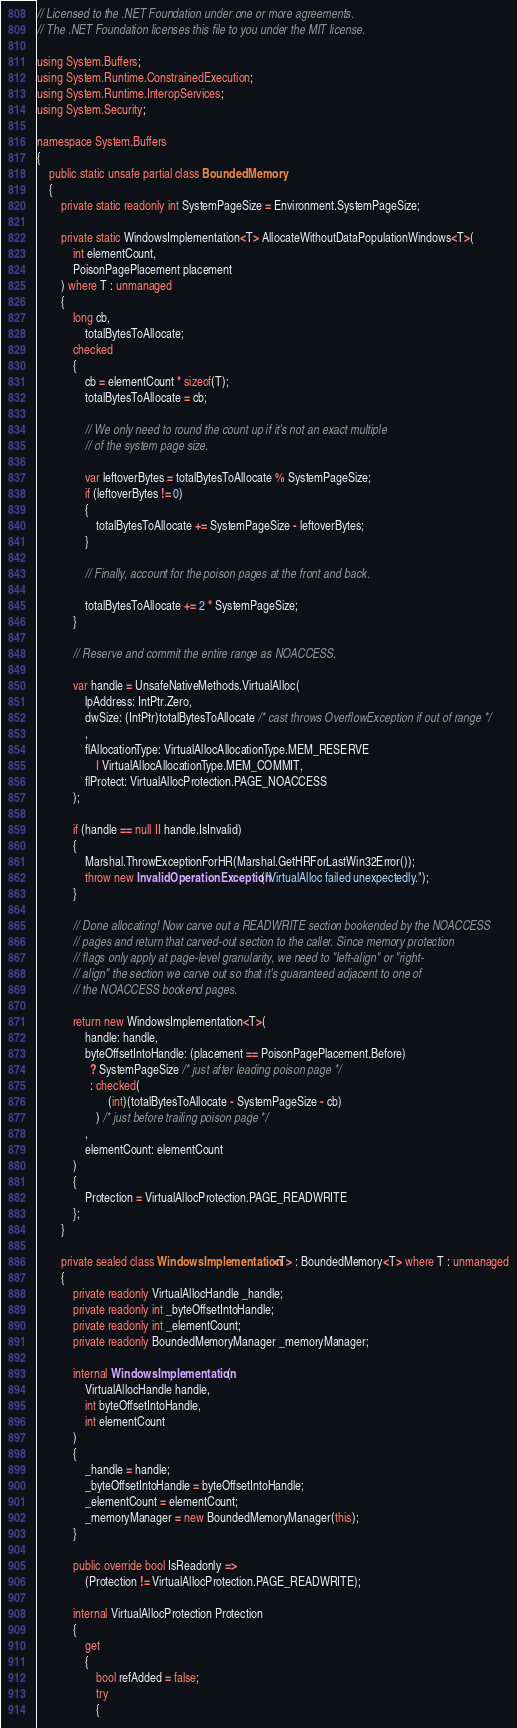Convert code to text. <code><loc_0><loc_0><loc_500><loc_500><_C#_>// Licensed to the .NET Foundation under one or more agreements.
// The .NET Foundation licenses this file to you under the MIT license.

using System.Buffers;
using System.Runtime.ConstrainedExecution;
using System.Runtime.InteropServices;
using System.Security;

namespace System.Buffers
{
    public static unsafe partial class BoundedMemory
    {
        private static readonly int SystemPageSize = Environment.SystemPageSize;

        private static WindowsImplementation<T> AllocateWithoutDataPopulationWindows<T>(
            int elementCount,
            PoisonPagePlacement placement
        ) where T : unmanaged
        {
            long cb,
                totalBytesToAllocate;
            checked
            {
                cb = elementCount * sizeof(T);
                totalBytesToAllocate = cb;

                // We only need to round the count up if it's not an exact multiple
                // of the system page size.

                var leftoverBytes = totalBytesToAllocate % SystemPageSize;
                if (leftoverBytes != 0)
                {
                    totalBytesToAllocate += SystemPageSize - leftoverBytes;
                }

                // Finally, account for the poison pages at the front and back.

                totalBytesToAllocate += 2 * SystemPageSize;
            }

            // Reserve and commit the entire range as NOACCESS.

            var handle = UnsafeNativeMethods.VirtualAlloc(
                lpAddress: IntPtr.Zero,
                dwSize: (IntPtr)totalBytesToAllocate /* cast throws OverflowException if out of range */
                ,
                flAllocationType: VirtualAllocAllocationType.MEM_RESERVE
                    | VirtualAllocAllocationType.MEM_COMMIT,
                flProtect: VirtualAllocProtection.PAGE_NOACCESS
            );

            if (handle == null || handle.IsInvalid)
            {
                Marshal.ThrowExceptionForHR(Marshal.GetHRForLastWin32Error());
                throw new InvalidOperationException("VirtualAlloc failed unexpectedly.");
            }

            // Done allocating! Now carve out a READWRITE section bookended by the NOACCESS
            // pages and return that carved-out section to the caller. Since memory protection
            // flags only apply at page-level granularity, we need to "left-align" or "right-
            // align" the section we carve out so that it's guaranteed adjacent to one of
            // the NOACCESS bookend pages.

            return new WindowsImplementation<T>(
                handle: handle,
                byteOffsetIntoHandle: (placement == PoisonPagePlacement.Before)
                  ? SystemPageSize /* just after leading poison page */
                  : checked(
                        (int)(totalBytesToAllocate - SystemPageSize - cb)
                    ) /* just before trailing poison page */
                ,
                elementCount: elementCount
            )
            {
                Protection = VirtualAllocProtection.PAGE_READWRITE
            };
        }

        private sealed class WindowsImplementation<T> : BoundedMemory<T> where T : unmanaged
        {
            private readonly VirtualAllocHandle _handle;
            private readonly int _byteOffsetIntoHandle;
            private readonly int _elementCount;
            private readonly BoundedMemoryManager _memoryManager;

            internal WindowsImplementation(
                VirtualAllocHandle handle,
                int byteOffsetIntoHandle,
                int elementCount
            )
            {
                _handle = handle;
                _byteOffsetIntoHandle = byteOffsetIntoHandle;
                _elementCount = elementCount;
                _memoryManager = new BoundedMemoryManager(this);
            }

            public override bool IsReadonly =>
                (Protection != VirtualAllocProtection.PAGE_READWRITE);

            internal VirtualAllocProtection Protection
            {
                get
                {
                    bool refAdded = false;
                    try
                    {</code> 